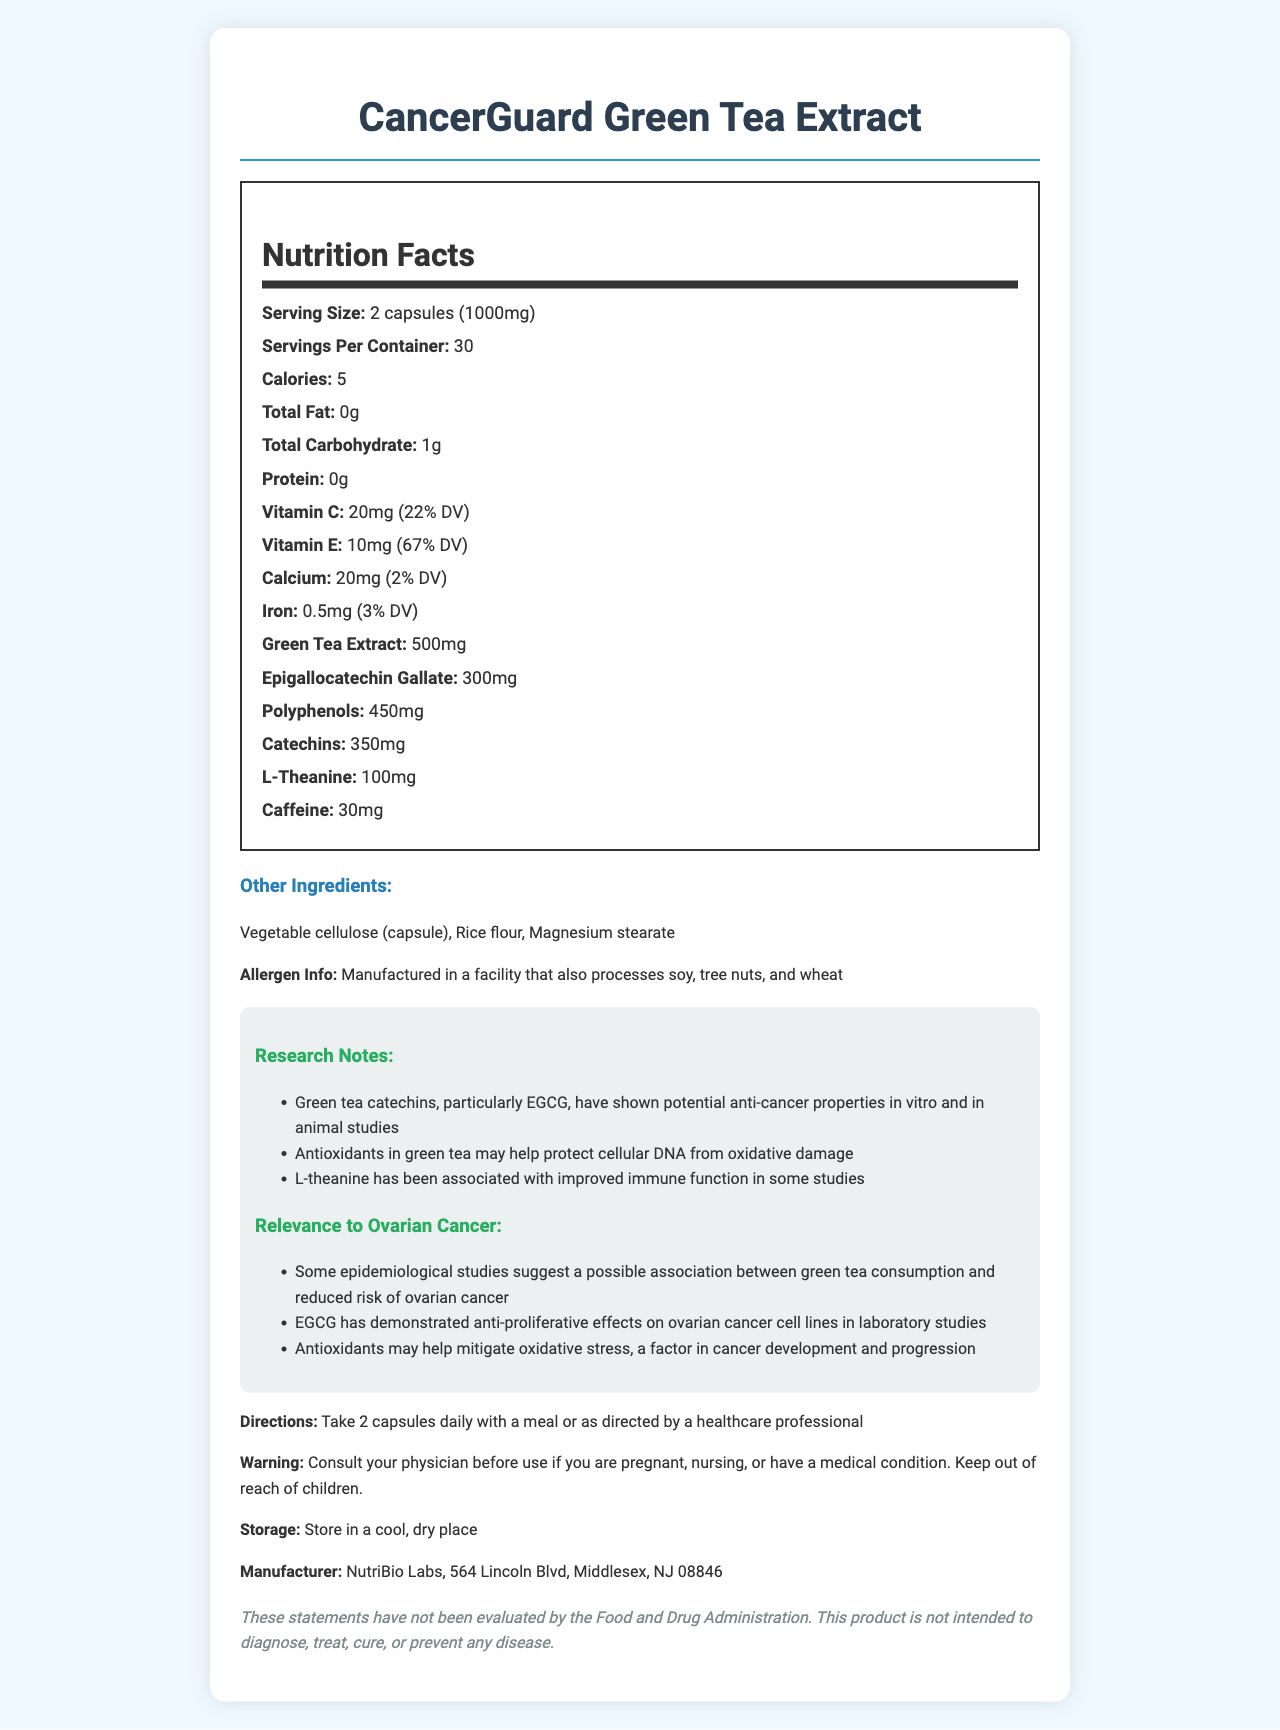what is the serving size of CancerGuard Green Tea Extract? The serving size is listed as "2 capsules (1000mg)" in the document.
Answer: 2 capsules (1000mg) how many calories are there per serving? The document indicates that each serving contains 5 calories.
Answer: 5 what is the amount of green tea extract per serving? According to the document, each serving contains 500mg of green tea extract.
Answer: 500mg name three key active ingredients in the supplement besides green tea extract. The document lists Epigallocatechin Gallate (300mg), Polyphenols (450mg), and Catechins (350mg) as key active ingredients besides the green tea extract.
Answer: Epigallocatechin Gallate, Polyphenols, Catechins where is the manufacturer of CancerGuard Green Tea Extract located? The manufacturer information in the document states "NutriBio Labs, 564 Lincoln Blvd, Middlesex, NJ 08846".
Answer: Middlesex, NJ 08846 what is the daily value percentage of Vitamin E per serving? The document states that Vitamin E provides 67% of the daily value per serving.
Answer: 67% which antioxidants are highlighted in the research notes for their potential cancer-fighting properties? A. Vitamin C and Vitamin E B. Epigallocatechin Gallate and Polyphenols C. Calcium and Iron The research notes mention that Green tea catechins, particularly EGCG, and antioxidants in green tea have potential anti-cancer properties, indicating Epigallocatechin Gallate and Polyphenols.
Answer: B how much L-theanine is in each serving? A. 100mg B. 300mg C. 450mg D. 500mg The document lists 100mg of L-theanine per serving.
Answer: A does this product contain any protein? The document indicates that the product has 0g of protein per serving.
Answer: No what kind of facility processes this supplement in terms of allergens? The allergen information states that it is manufactured in a facility that also processes soy, tree nuts, and wheat.
Answer: A facility that also processes soy, tree nuts, and wheat what conclusion can be made about the potential benefits of this green tea supplement in relation to ovarian cancer? The research notes and relevance to ovarian cancer sections both indicate that certain components in the green tea extract have shown anti-cancer properties and that green tea consumption might be associated with a reduced risk of ovarian cancer.
Answer: The supplement contains components that have shown potential anti-cancer properties in vitro and in animal studies, and epidemiological studies suggest a possible association between green tea consumption and a reduced risk of ovarian cancer. what are the potential side effects of taking this supplement if you have certain medical conditions? The warning statement advises consulting a physician before use if pregnant, nursing, or having a medical condition.
Answer: Consult your physician before use if you are pregnant, nursing, or have a medical condition. how should this supplement be stored? The storage instructions state to store the supplement in a cool, dry place.
Answer: Store in a cool, dry place summarize the main idea of the document. The document outlines the product's nutrition facts, benefits, key ingredients, and additional information crucial for consumers, especially those interested in its potential cancer-fighting properties.
Answer: The document provides detailed information about CancerGuard Green Tea Extract, an antioxidant-rich supplement. It includes nutritional information, active and inactive ingredients, research notes, relevance to ovarian cancer, directions for use, allergen information, and manufacturer details. what clinical trials support the claims in this document? The document does not provide specific information or references to clinical trials supporting the claims made.
Answer: Cannot be determined 